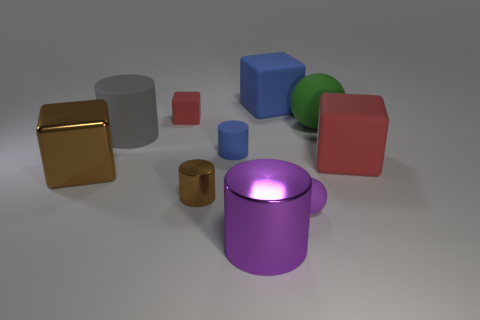Are there any big objects of the same color as the small matte cylinder?
Offer a very short reply. Yes. There is a rubber object that is the same color as the big shiny cylinder; what is its size?
Make the answer very short. Small. What number of things are either purple matte things on the right side of the big gray object or small balls in front of the large gray matte thing?
Your answer should be compact. 1. Are there any tiny red rubber blocks behind the green rubber ball?
Your answer should be compact. Yes. What color is the big cube in front of the red cube that is in front of the sphere that is behind the tiny brown cylinder?
Provide a succinct answer. Brown. Do the big purple object and the tiny brown thing have the same shape?
Give a very brief answer. Yes. There is a cube that is made of the same material as the small brown cylinder; what is its color?
Offer a terse response. Brown. How many objects are either big cubes that are to the right of the small brown metal thing or green cylinders?
Your answer should be compact. 2. What size is the red object left of the tiny purple matte thing?
Your answer should be very brief. Small. There is a purple cylinder; does it have the same size as the matte sphere in front of the small blue thing?
Give a very brief answer. No. 